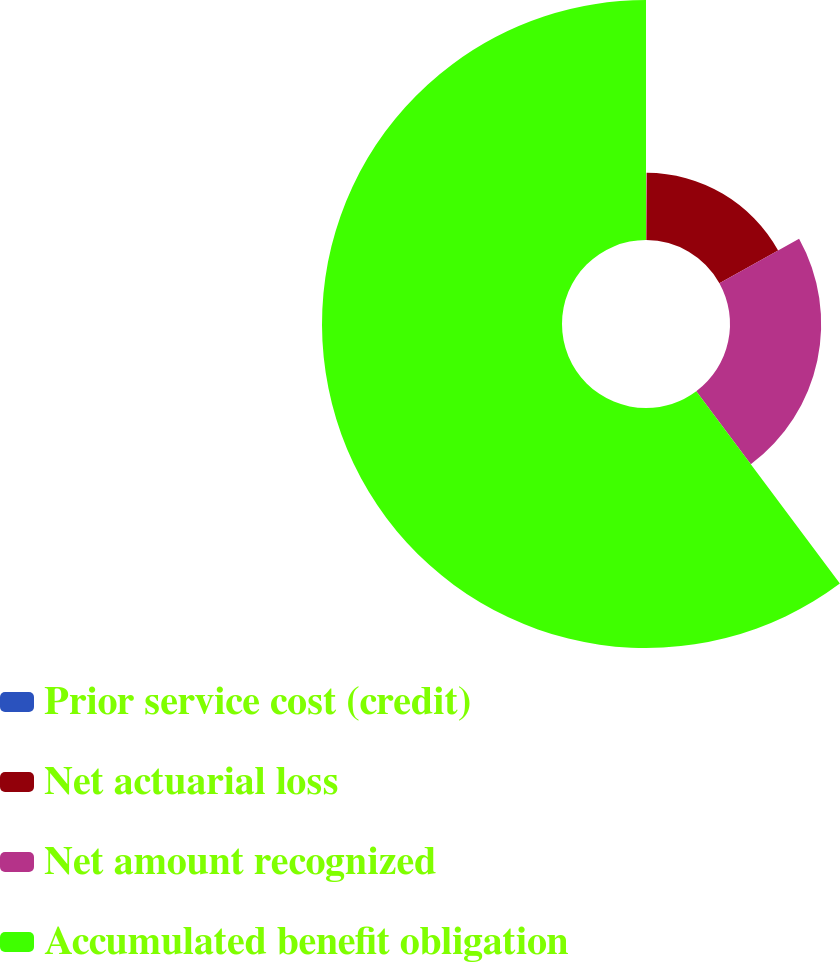Convert chart to OTSL. <chart><loc_0><loc_0><loc_500><loc_500><pie_chart><fcel>Prior service cost (credit)<fcel>Net actuarial loss<fcel>Net amount recognized<fcel>Accumulated benefit obligation<nl><fcel>0.06%<fcel>16.86%<fcel>22.87%<fcel>60.21%<nl></chart> 